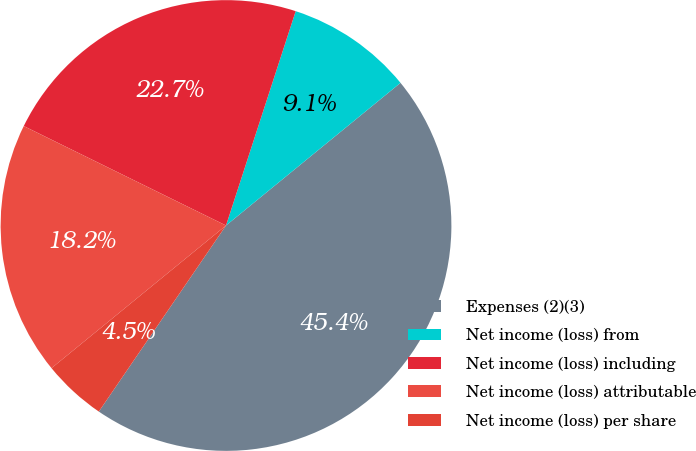Convert chart to OTSL. <chart><loc_0><loc_0><loc_500><loc_500><pie_chart><fcel>Expenses (2)(3)<fcel>Net income (loss) from<fcel>Net income (loss) including<fcel>Net income (loss) attributable<fcel>Net income (loss) per share<nl><fcel>45.45%<fcel>9.09%<fcel>22.73%<fcel>18.18%<fcel>4.55%<nl></chart> 